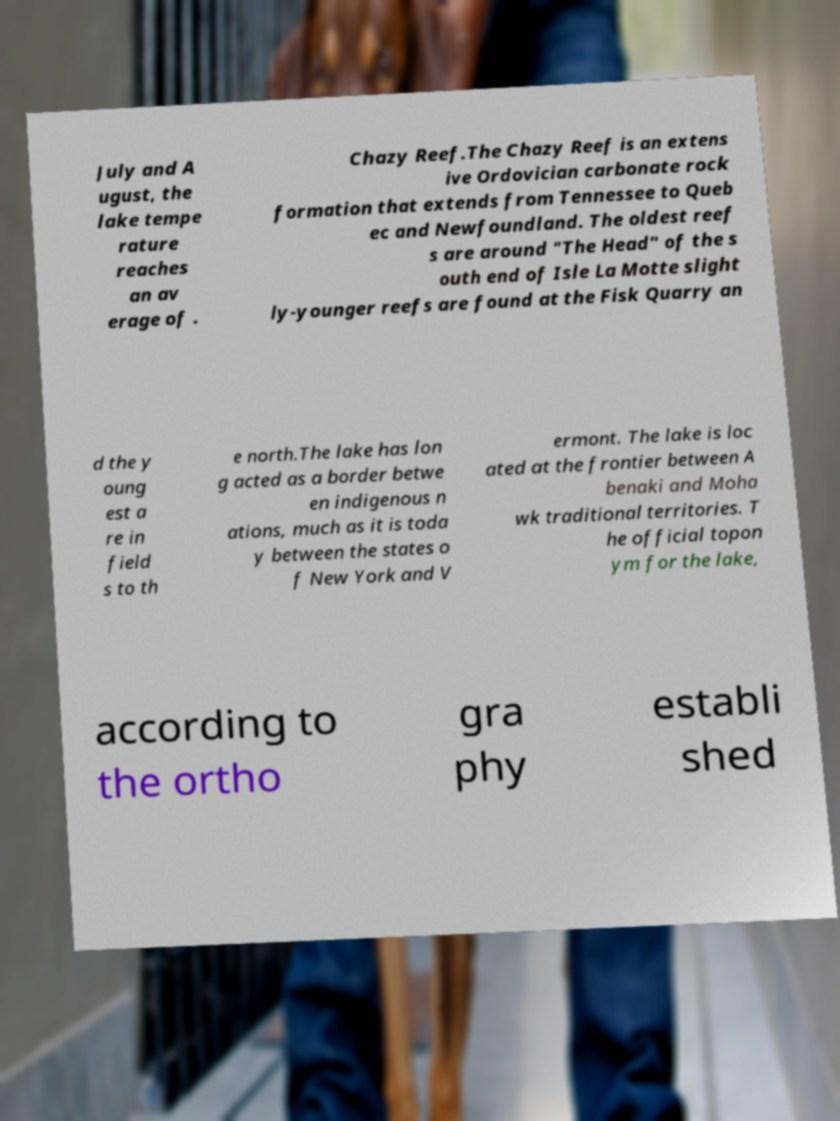Please read and relay the text visible in this image. What does it say? July and A ugust, the lake tempe rature reaches an av erage of . Chazy Reef.The Chazy Reef is an extens ive Ordovician carbonate rock formation that extends from Tennessee to Queb ec and Newfoundland. The oldest reef s are around "The Head" of the s outh end of Isle La Motte slight ly-younger reefs are found at the Fisk Quarry an d the y oung est a re in field s to th e north.The lake has lon g acted as a border betwe en indigenous n ations, much as it is toda y between the states o f New York and V ermont. The lake is loc ated at the frontier between A benaki and Moha wk traditional territories. T he official topon ym for the lake, according to the ortho gra phy establi shed 